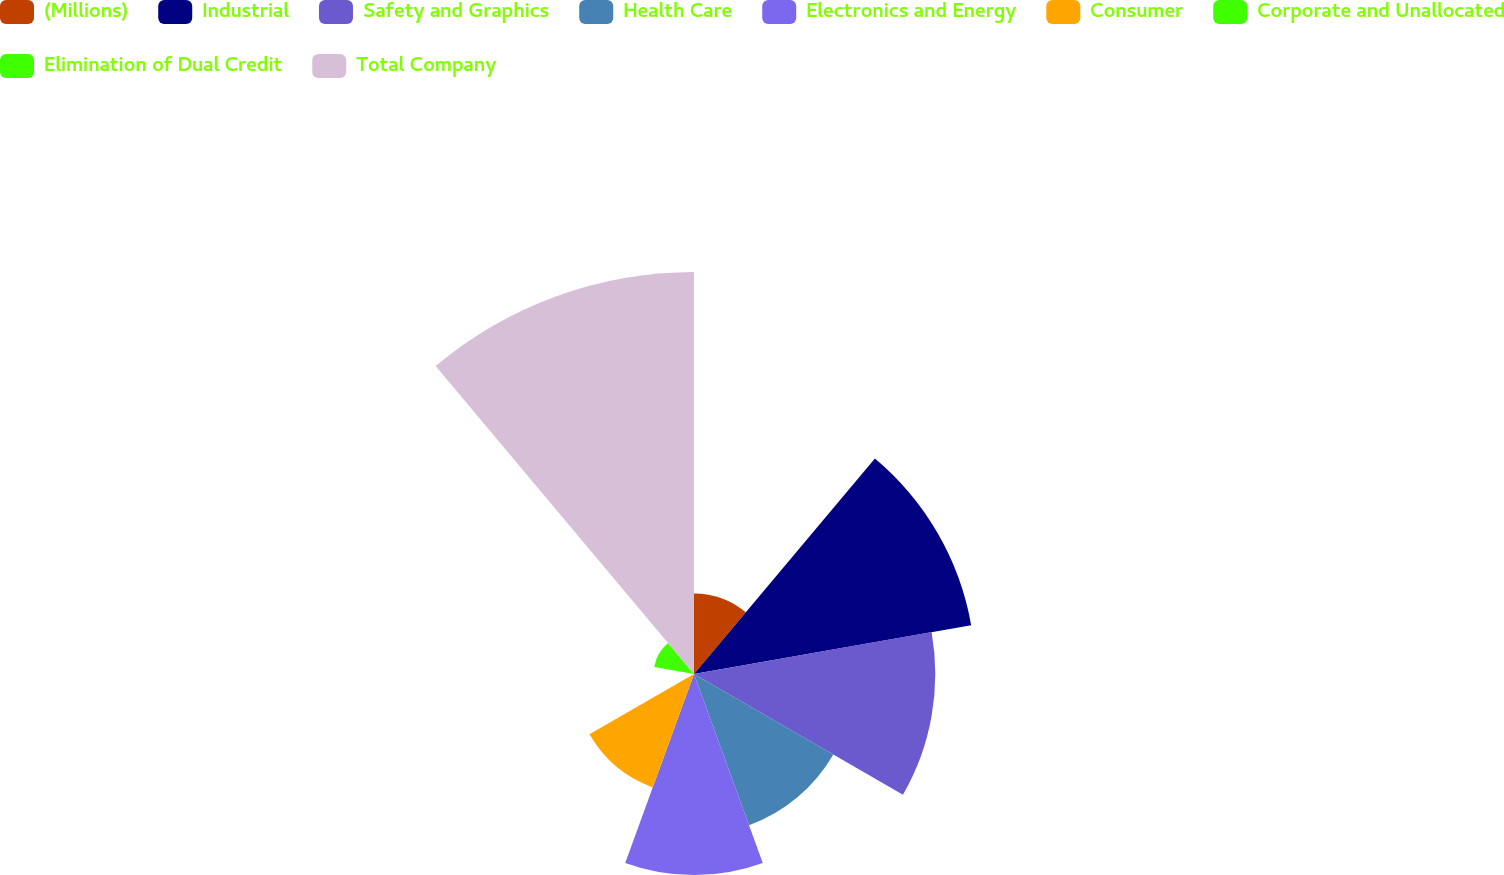Convert chart. <chart><loc_0><loc_0><loc_500><loc_500><pie_chart><fcel>(Millions)<fcel>Industrial<fcel>Safety and Graphics<fcel>Health Care<fcel>Electronics and Energy<fcel>Consumer<fcel>Corporate and Unallocated<fcel>Elimination of Dual Credit<fcel>Total Company<nl><fcel>5.27%<fcel>18.42%<fcel>15.79%<fcel>10.53%<fcel>13.16%<fcel>7.9%<fcel>0.01%<fcel>2.64%<fcel>26.31%<nl></chart> 